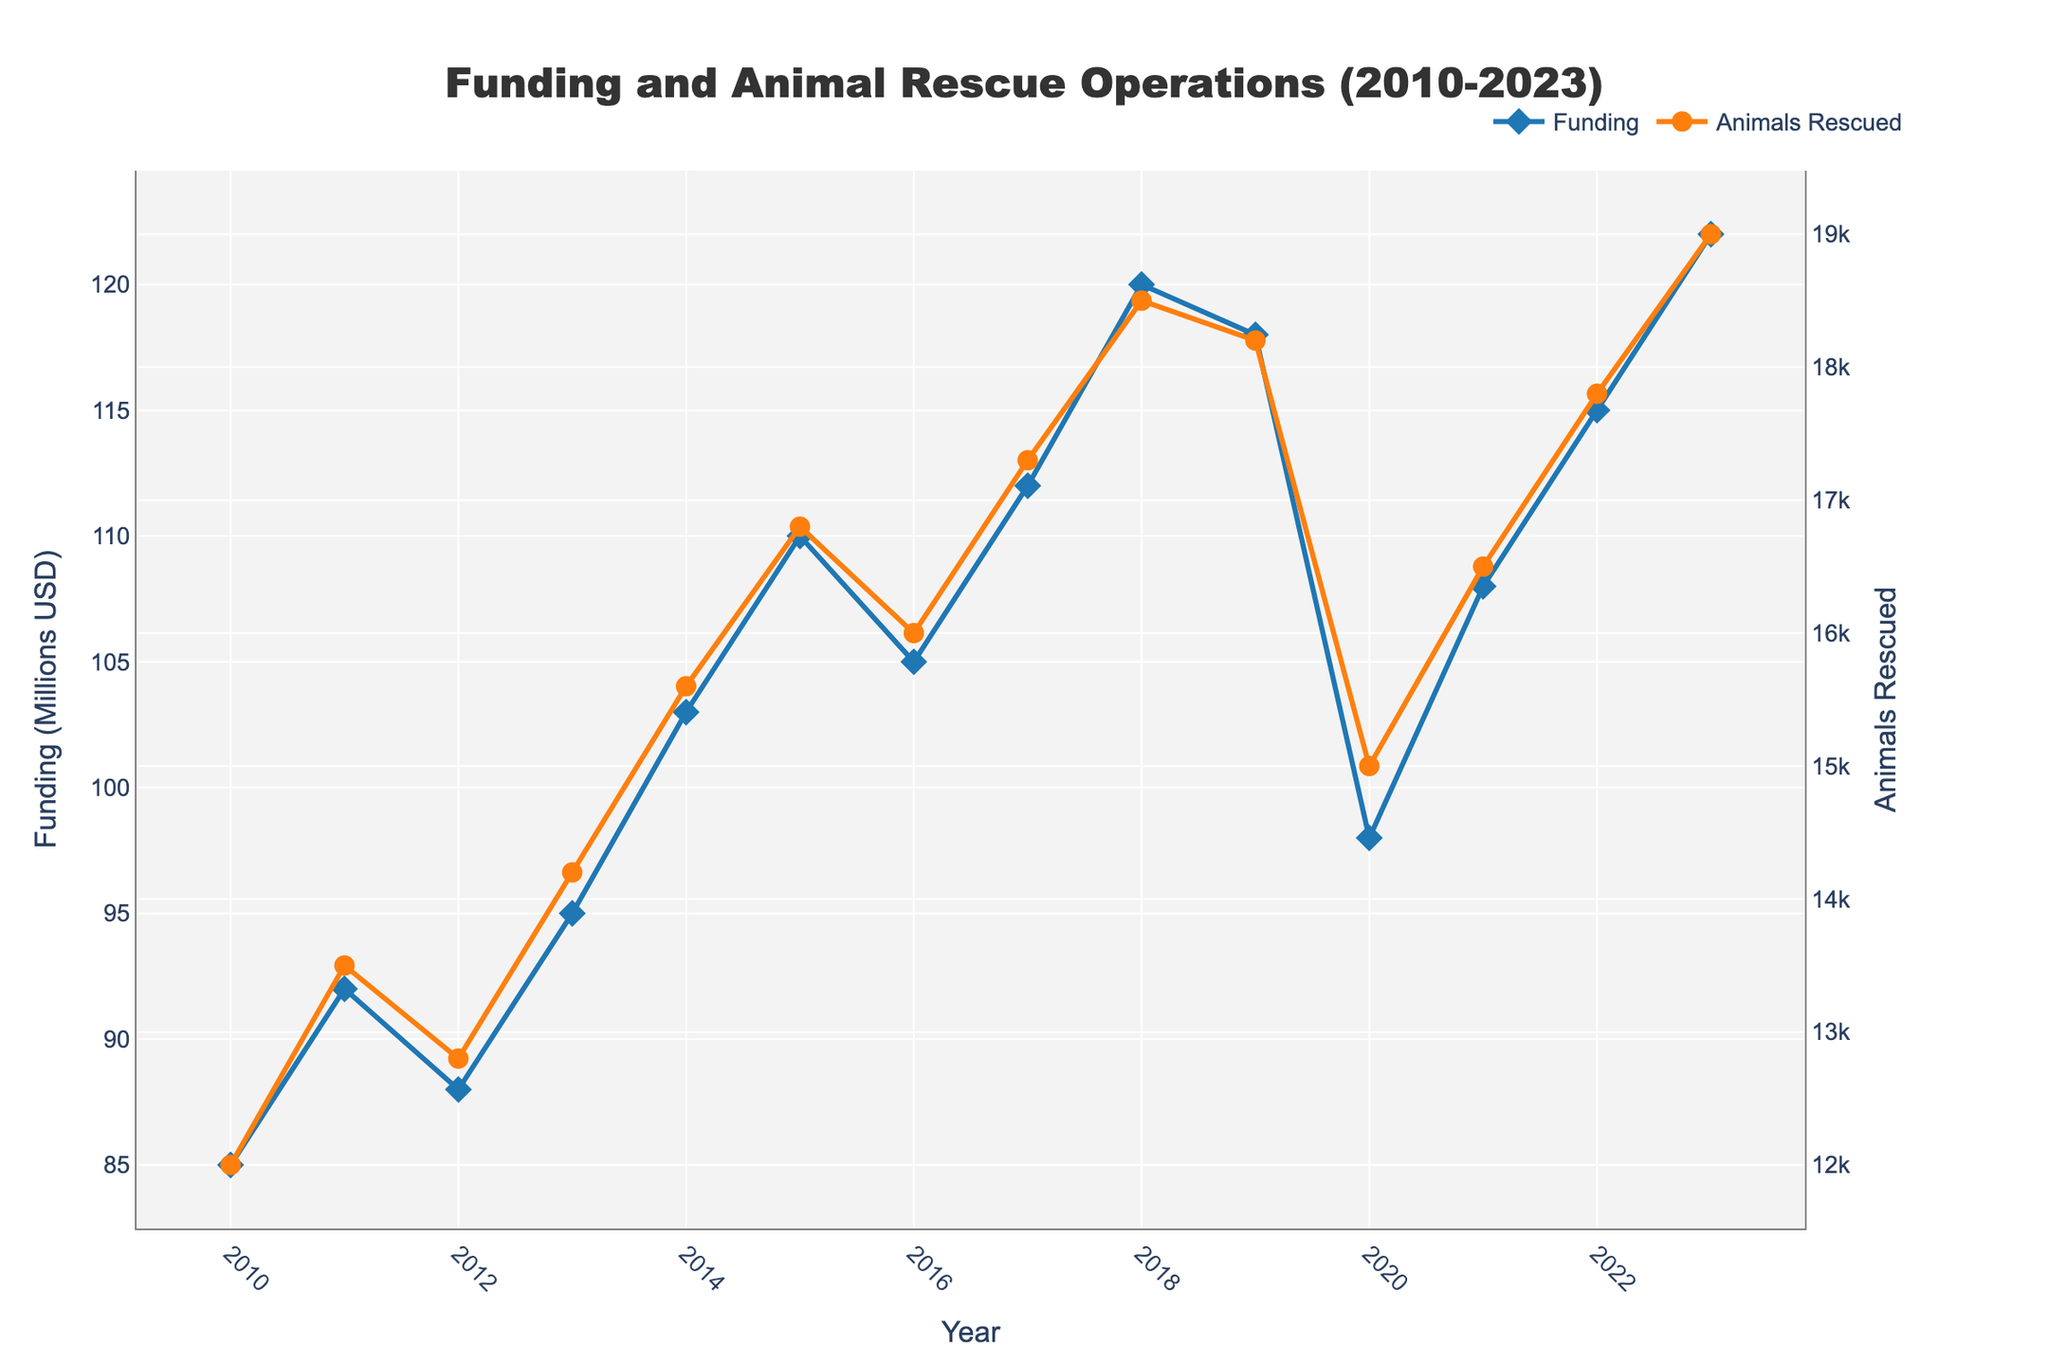How did the funding allocated to animal welfare organizations change from 2010 to 2023? To determine how the funding allocated to animal welfare organizations changed from 2010 to 2023, we can observe the first and last data points on the blue line representing funding. In 2010, the funding was 85 million USD, and in 2023, it was 122 million USD. This indicates an increase in funding over the period.
Answer: Increase In which year was the highest number of animals rescued and how many were rescued that year? By examining the highest point on the orange line representing the number of animals rescued, we see that 2023 had the highest number, with 19,000 animals rescued.
Answer: 2023, 19,000 Which year saw the largest drop in funding compared to the previous year? We can identify the largest drop by comparing year-over-year funding changes. The largest drop in funding occurred from 2019 to 2020, where funding decreased from 118 million USD to 98 million USD.
Answer: 2020 Did the number of animals rescued decrease at any point during the period from 2010 to 2023, and if so, when? Observing the orange line, we notice a decrease in the number of animals rescued from 2019 (18,200) to 2020 (15,000).
Answer: Yes, 2020 What is the relationship between the trend in funding and the number of animals rescued over the years? By examining the overall trend of both lines, we see that both funding and the number of animals rescued generally increased over the years, indicating a positive correlation. When funding increased, the number of animals rescued also tended to increase, although there are exceptions such as 2019-2020.
Answer: Positive correlation Compare the funding in 2015 with 2020 and state the difference. In 2015, the funding was 110 million USD and in 2020, it was 98 million USD. The difference is 110 - 98 = 12 million USD.
Answer: 12 million USD What was the average annual funding between 2010 and 2023? To calculate the average annual funding, we sum the funding amounts from all years and divide by the number of years: (85 + 92 + 88 + 95 + 103 + 110 + 105 + 112 + 120 + 118 + 98 + 108 + 115 + 122) / 14 = 1201 / 14 ≈ 85.79 million USD.
Answer: 85.79 million USD By how much did the number of animals rescued increase from 2010 to 2023? The number of animals rescued in 2010 was 12,000, and in 2023 it was 19,000. The increase is 19,000 - 12,000 = 7,000 animals.
Answer: 7,000 animals What was the difference in funding between the years with the highest and lowest number of animals rescued? The highest number of animals rescued was in 2023 with 19,000 animals, with a funding of 122 million USD. The lowest was in 2010 with 12,000 animals, with a funding of 85 million USD. The difference in funding is 122 - 85 = 37 million USD.
Answer: 37 million USD Was there a year when funding was high, but the number of animals rescued did not increase significantly? Examining the lines, we observe that from 2018 to 2019, funding was relatively high (120 million USD to 118 million USD), but the number of animals rescued slightly decreased from 18,500 to 18,200.
Answer: Yes, 2019 